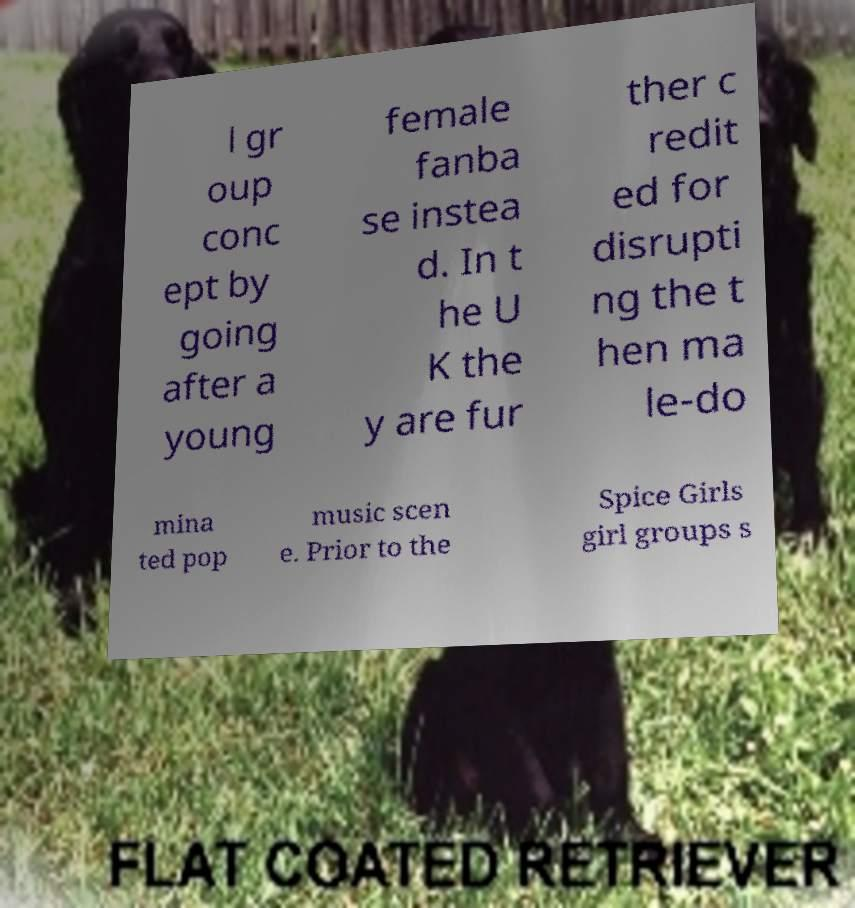I need the written content from this picture converted into text. Can you do that? l gr oup conc ept by going after a young female fanba se instea d. In t he U K the y are fur ther c redit ed for disrupti ng the t hen ma le-do mina ted pop music scen e. Prior to the Spice Girls girl groups s 